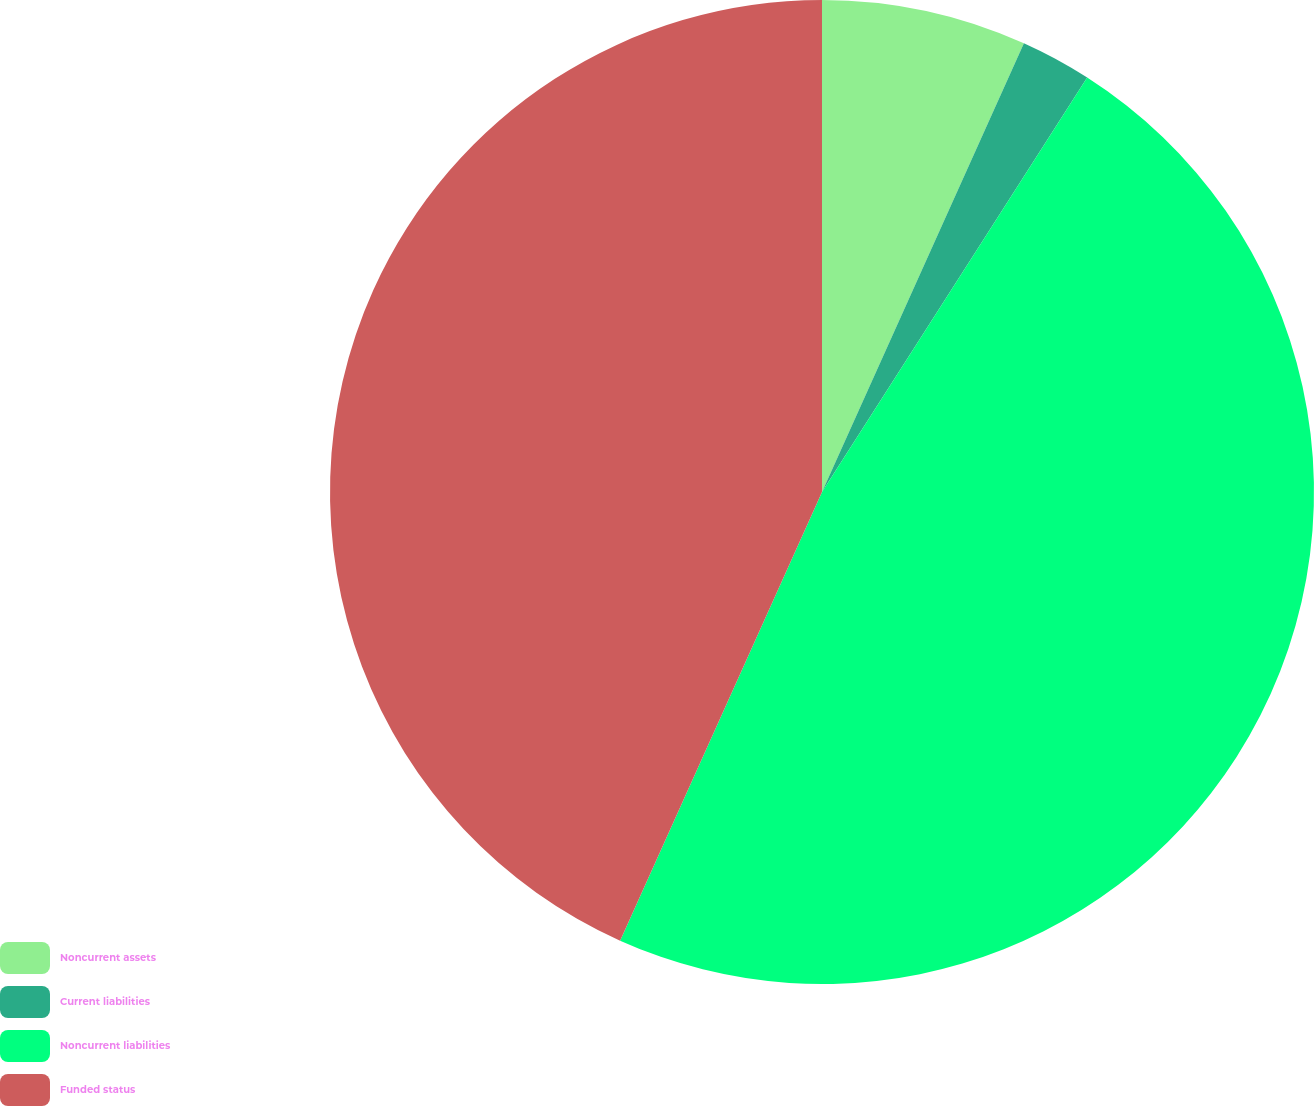<chart> <loc_0><loc_0><loc_500><loc_500><pie_chart><fcel>Noncurrent assets<fcel>Current liabilities<fcel>Noncurrent liabilities<fcel>Funded status<nl><fcel>6.73%<fcel>2.33%<fcel>47.67%<fcel>43.27%<nl></chart> 